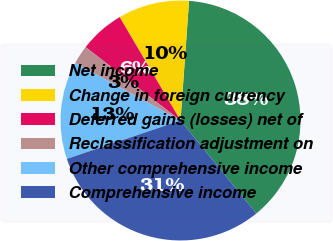Convert chart. <chart><loc_0><loc_0><loc_500><loc_500><pie_chart><fcel>Net income<fcel>Change in foreign currency<fcel>Deferred gains (losses) net of<fcel>Reclassification adjustment on<fcel>Other comprehensive income<fcel>Comprehensive income<nl><fcel>37.98%<fcel>9.6%<fcel>6.06%<fcel>2.51%<fcel>13.15%<fcel>30.7%<nl></chart> 